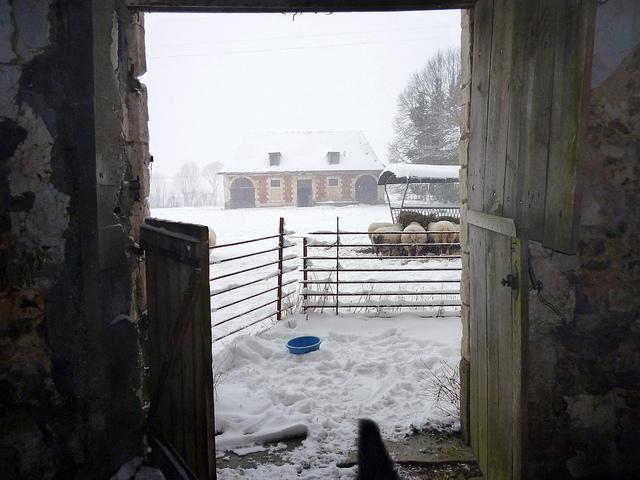From what kind of building was this picture taken?
From the following four choices, select the correct answer to address the question.
Options: Silo, barn, house, trailer. Barn. 